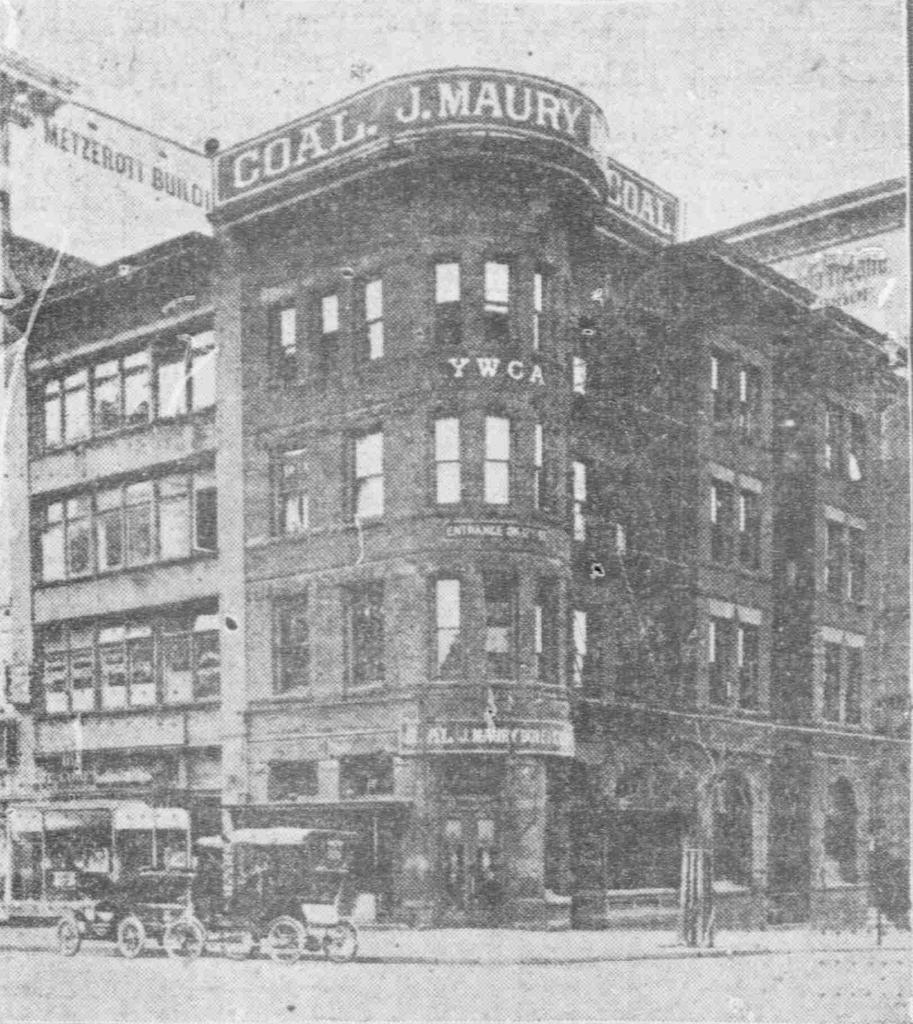What is the color scheme of the image? The image is black and white. Can you describe the age of the image? The image is old. What is the main structure in the image? There is a big building in the image. What is located in front of the building? There is a cart in front of the building. What type of robin can be seen sitting on the roof of the building in the image? There is no robin present in the image; it is a black and white image of a building with a cart in front of it. 